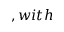Convert formula to latex. <formula><loc_0><loc_0><loc_500><loc_500>, w i t h</formula> 